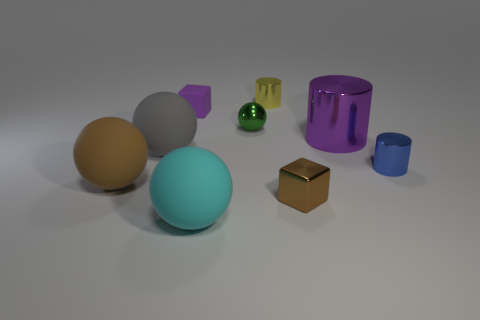Is the green object made of the same material as the small blue object?
Offer a very short reply. Yes. How many objects are matte cubes or small brown blocks?
Provide a short and direct response. 2. How many purple cubes have the same material as the blue cylinder?
Your response must be concise. 0. What is the size of the brown object that is the same shape as the large gray rubber thing?
Your answer should be compact. Large. There is a purple shiny thing; are there any small metal things right of it?
Your response must be concise. Yes. What is the blue cylinder made of?
Make the answer very short. Metal. There is a big object on the right side of the cyan thing; does it have the same color as the matte block?
Offer a terse response. Yes. The tiny shiny object that is the same shape as the brown rubber object is what color?
Provide a succinct answer. Green. What is the material of the tiny cylinder that is behind the blue shiny cylinder?
Give a very brief answer. Metal. What color is the large metallic thing?
Offer a very short reply. Purple. 